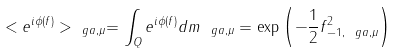<formula> <loc_0><loc_0><loc_500><loc_500>< e ^ { i \phi ( f ) } > _ { \ g a , \mu } = \int _ { Q } e ^ { i \phi ( f ) } d m _ { \ g a , \mu } = \exp \left ( - \frac { 1 } { 2 } \| f \| ^ { 2 } _ { - 1 , \ g a , \mu } \right )</formula> 